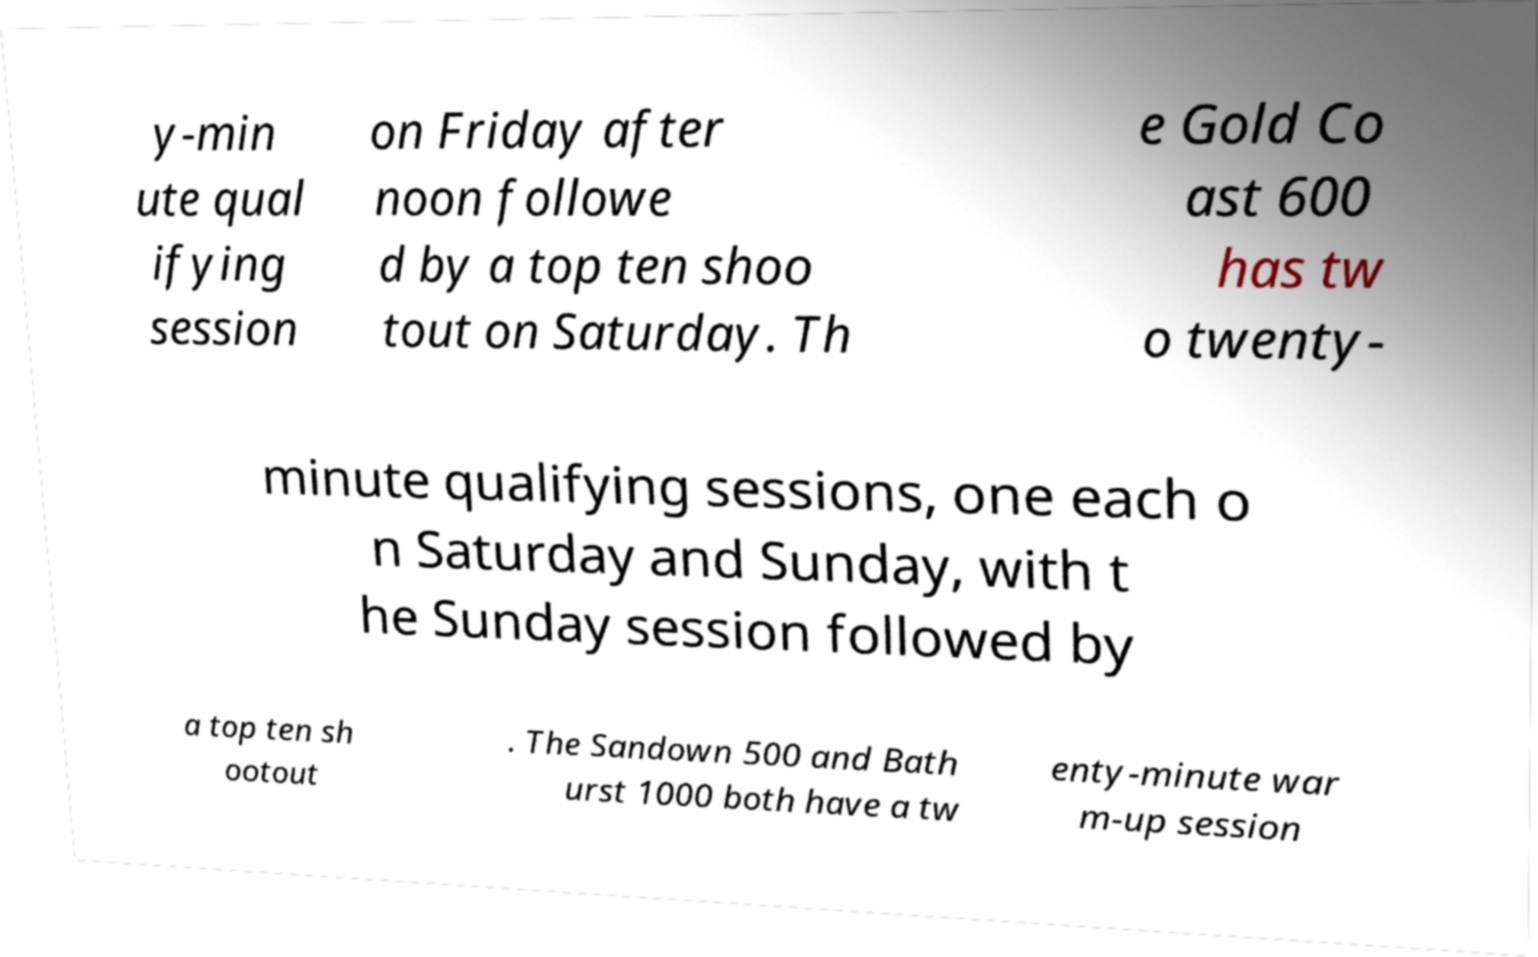Please identify and transcribe the text found in this image. y-min ute qual ifying session on Friday after noon followe d by a top ten shoo tout on Saturday. Th e Gold Co ast 600 has tw o twenty- minute qualifying sessions, one each o n Saturday and Sunday, with t he Sunday session followed by a top ten sh ootout . The Sandown 500 and Bath urst 1000 both have a tw enty-minute war m-up session 